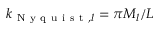Convert formula to latex. <formula><loc_0><loc_0><loc_500><loc_500>k _ { N y q u i s t , l } = \pi M _ { l } / L</formula> 